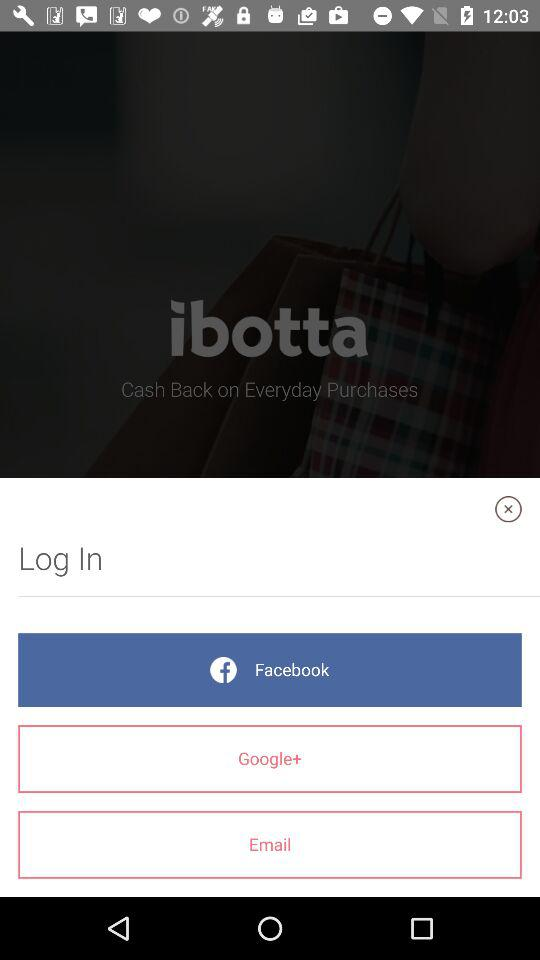Through what application can we log in? You can log in through "Facebook". 